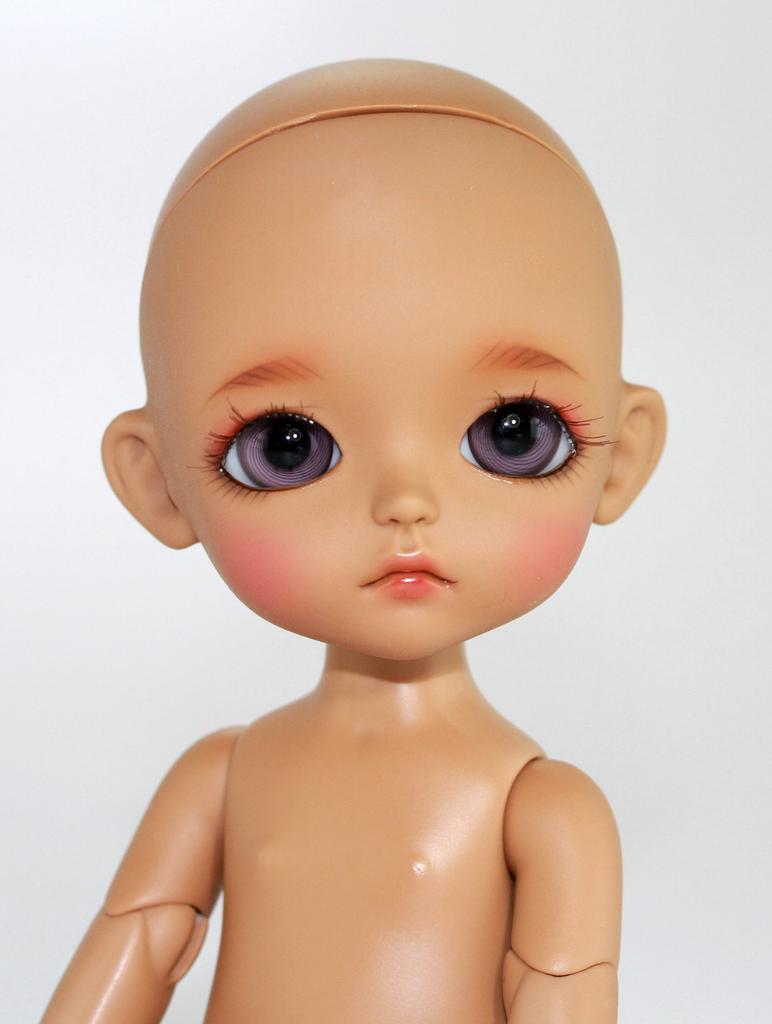Please provide a concise description of this image. In this image I can see a doll which is brown in color and I can see the white colored background. 